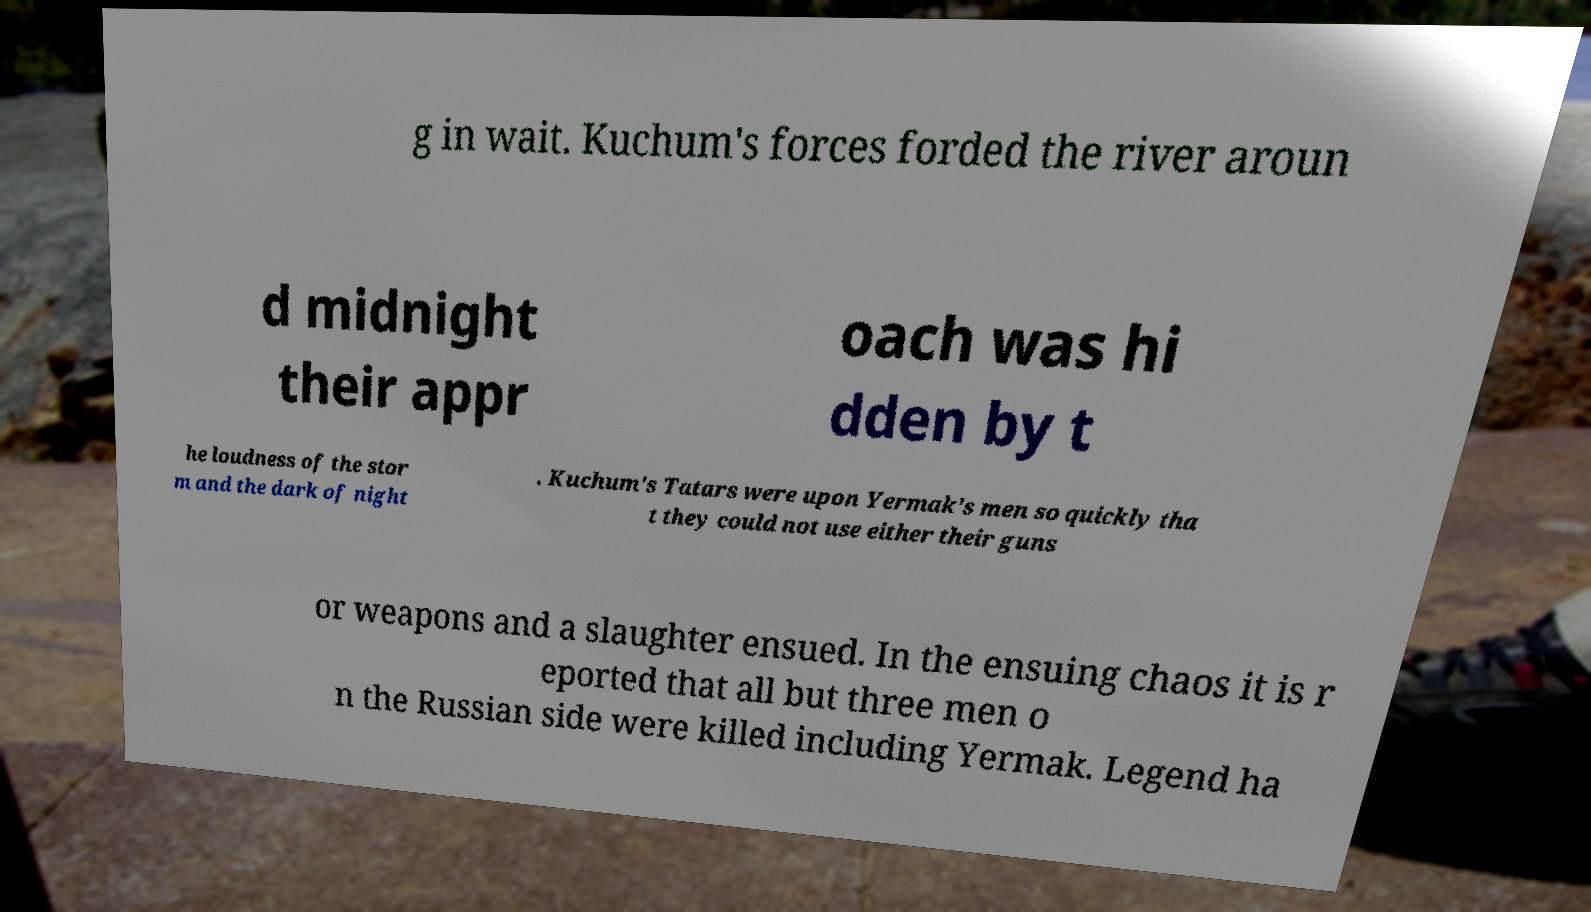Can you read and provide the text displayed in the image?This photo seems to have some interesting text. Can you extract and type it out for me? g in wait. Kuchum's forces forded the river aroun d midnight their appr oach was hi dden by t he loudness of the stor m and the dark of night . Kuchum's Tatars were upon Yermak's men so quickly tha t they could not use either their guns or weapons and a slaughter ensued. In the ensuing chaos it is r eported that all but three men o n the Russian side were killed including Yermak. Legend ha 